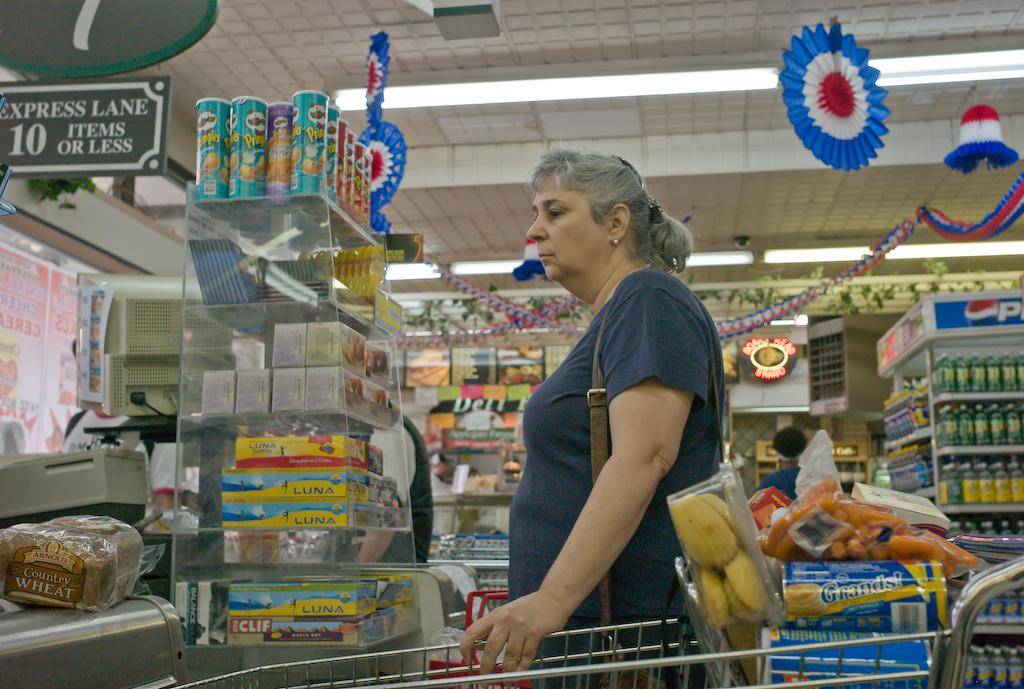Who is the main subject in the image? There is a woman standing in the middle of the picture. What is the woman standing on? The woman is standing on the floor. What object is beside the woman? There is a trolley beside the woman. What can be seen in the background of the image? There is a supermarket in the background of the image. What type of pan can be seen hanging from the ceiling in the image? There is no pan visible in the image; it is set in a supermarket with a woman and a trolley. 